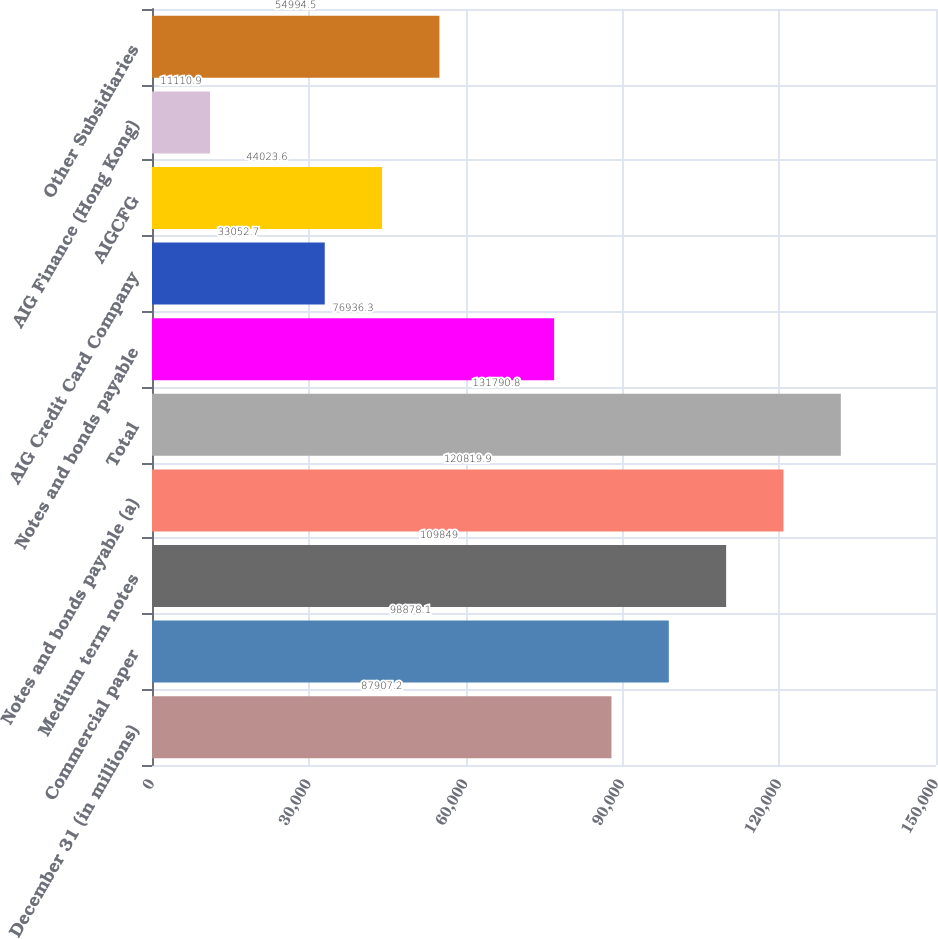Convert chart to OTSL. <chart><loc_0><loc_0><loc_500><loc_500><bar_chart><fcel>December 31 (in millions)<fcel>Commercial paper<fcel>Medium term notes<fcel>Notes and bonds payable (a)<fcel>Total<fcel>Notes and bonds payable<fcel>AIG Credit Card Company<fcel>AIGCFG<fcel>AIG Finance (Hong Kong)<fcel>Other Subsidiaries<nl><fcel>87907.2<fcel>98878.1<fcel>109849<fcel>120820<fcel>131791<fcel>76936.3<fcel>33052.7<fcel>44023.6<fcel>11110.9<fcel>54994.5<nl></chart> 